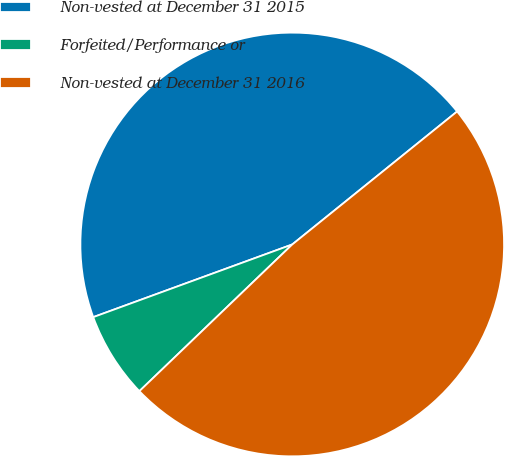<chart> <loc_0><loc_0><loc_500><loc_500><pie_chart><fcel>Non-vested at December 31 2015<fcel>Forfeited/Performance or<fcel>Non-vested at December 31 2016<nl><fcel>44.77%<fcel>6.6%<fcel>48.63%<nl></chart> 